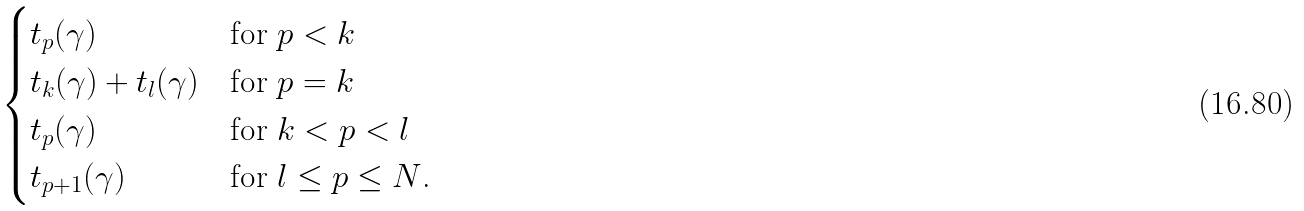Convert formula to latex. <formula><loc_0><loc_0><loc_500><loc_500>\begin{cases} t _ { p } ( \gamma ) & \text {for $p<k$} \\ t _ { k } ( \gamma ) + t _ { l } ( \gamma ) & \text {for $p=k$} \\ t _ { p } ( \gamma ) & \text {for $k<p<l$} \\ t _ { p + 1 } ( \gamma ) & \text {for $l \leq p\leq N$.} \end{cases}</formula> 